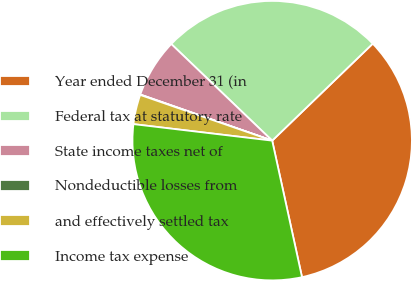<chart> <loc_0><loc_0><loc_500><loc_500><pie_chart><fcel>Year ended December 31 (in<fcel>Federal tax at statutory rate<fcel>State income taxes net of<fcel>Nondeductible losses from<fcel>and effectively settled tax<fcel>Income tax expense<nl><fcel>33.79%<fcel>25.63%<fcel>6.8%<fcel>0.05%<fcel>3.42%<fcel>30.31%<nl></chart> 